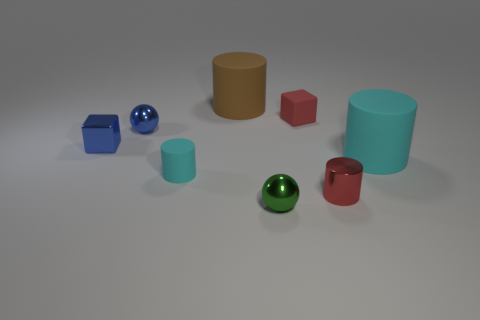What colors are the objects in the image, and which one stands out the most? The objects in the image include a blue cube, a shiny blue sphere, a red cube, a brown cylinder, a cyan cylinder, a green sphere, and a red cylinder. The shiny blue sphere stands out the most due to its reflective surface and vibrant color. Can you tell me about the lighting in the image? The lighting in the image appears to be coming from the upper left, casting soft shadows to the right of the objects. This even, diffused light suggests an indoor setting with controlled lighting conditions. 